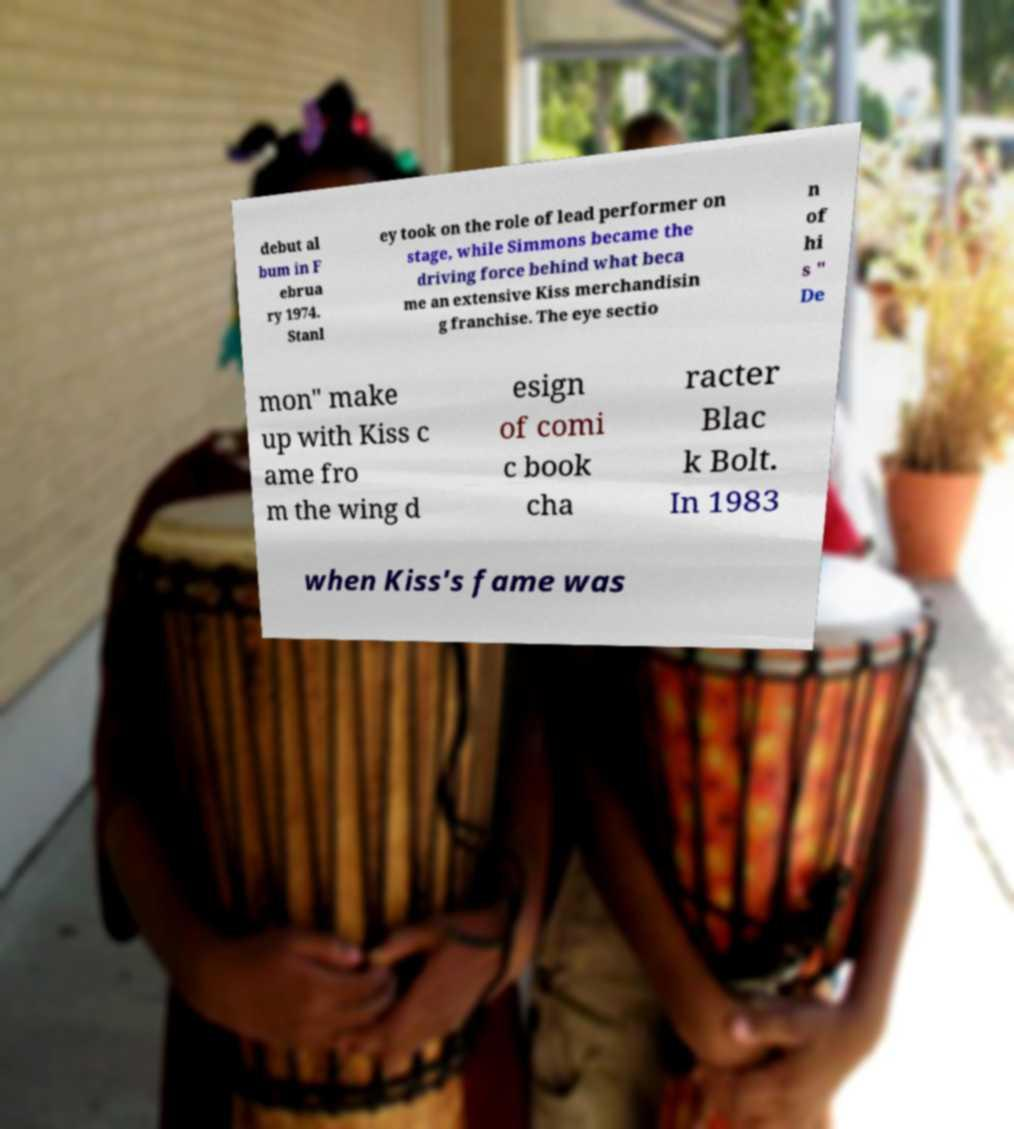Can you accurately transcribe the text from the provided image for me? debut al bum in F ebrua ry 1974. Stanl ey took on the role of lead performer on stage, while Simmons became the driving force behind what beca me an extensive Kiss merchandisin g franchise. The eye sectio n of hi s " De mon" make up with Kiss c ame fro m the wing d esign of comi c book cha racter Blac k Bolt. In 1983 when Kiss's fame was 